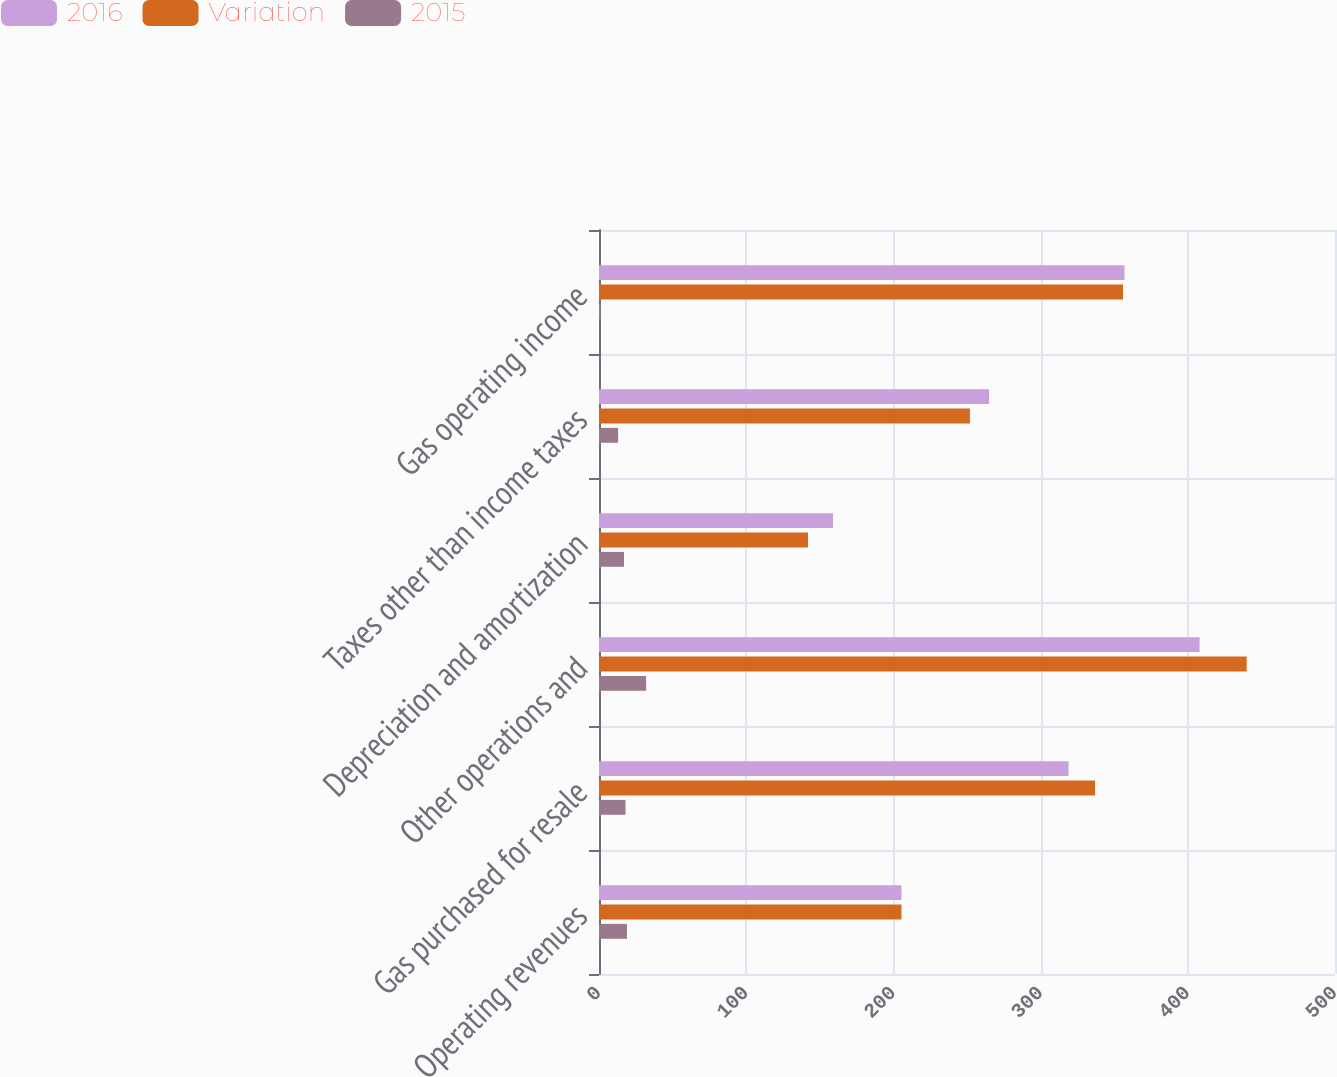Convert chart to OTSL. <chart><loc_0><loc_0><loc_500><loc_500><stacked_bar_chart><ecel><fcel>Operating revenues<fcel>Gas purchased for resale<fcel>Other operations and<fcel>Depreciation and amortization<fcel>Taxes other than income taxes<fcel>Gas operating income<nl><fcel>2016<fcel>205.5<fcel>319<fcel>408<fcel>159<fcel>265<fcel>357<nl><fcel>Variation<fcel>205.5<fcel>337<fcel>440<fcel>142<fcel>252<fcel>356<nl><fcel>2015<fcel>19<fcel>18<fcel>32<fcel>17<fcel>13<fcel>1<nl></chart> 